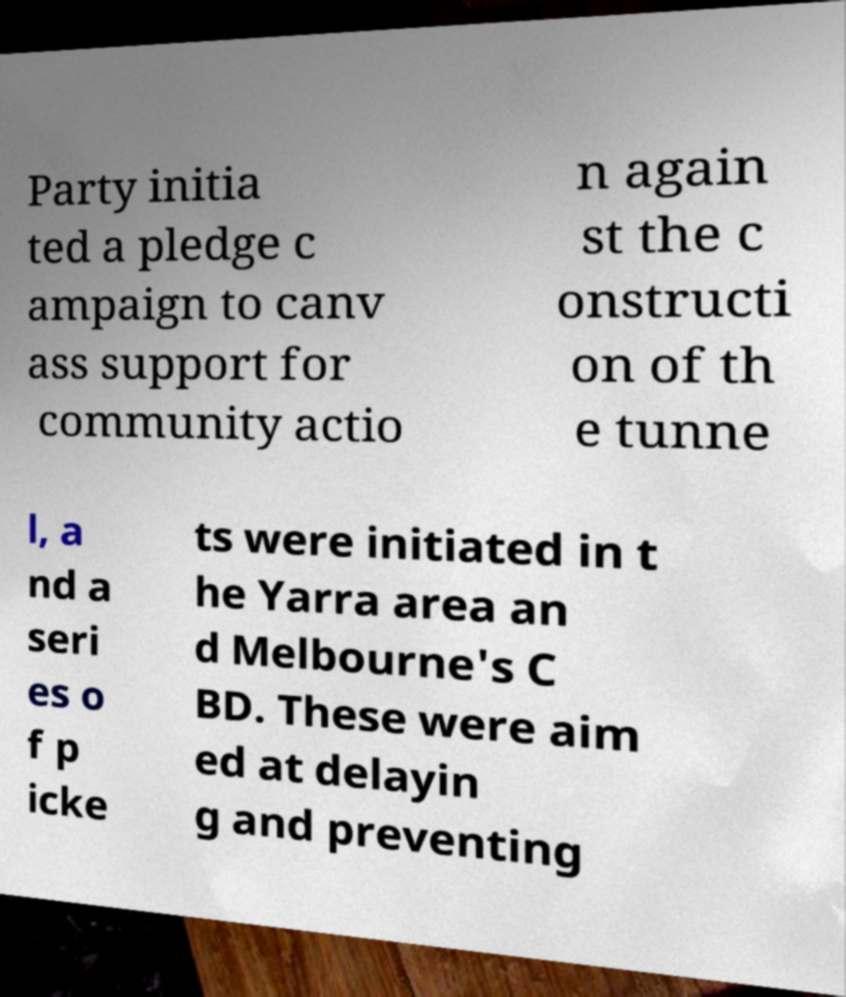Could you extract and type out the text from this image? Party initia ted a pledge c ampaign to canv ass support for community actio n again st the c onstructi on of th e tunne l, a nd a seri es o f p icke ts were initiated in t he Yarra area an d Melbourne's C BD. These were aim ed at delayin g and preventing 